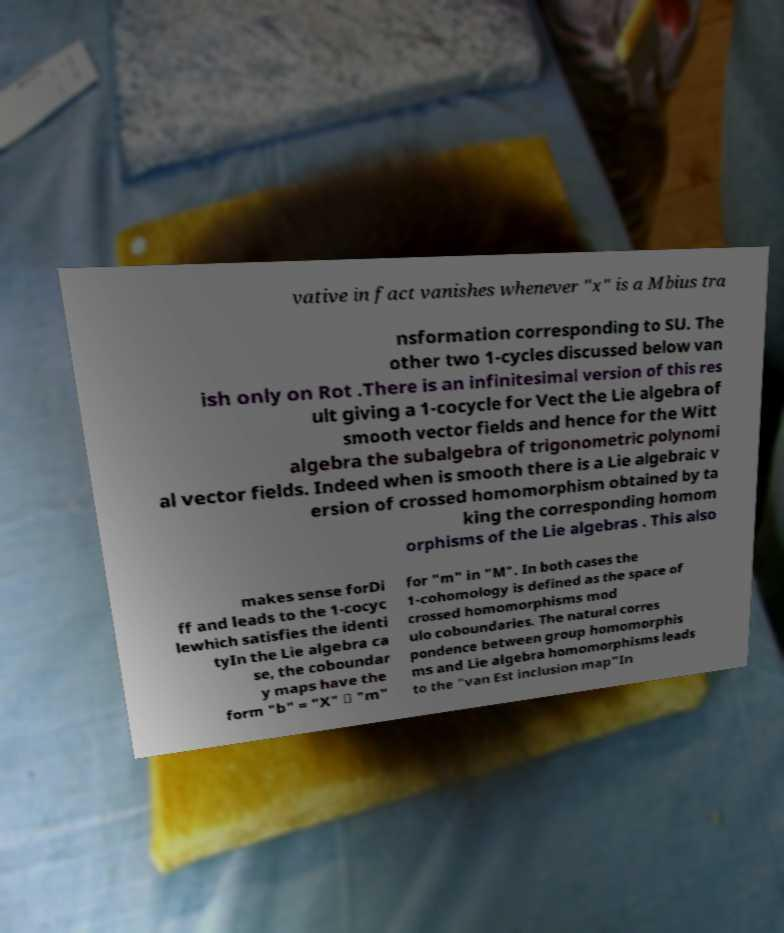Could you extract and type out the text from this image? vative in fact vanishes whenever "x" is a Mbius tra nsformation corresponding to SU. The other two 1-cycles discussed below van ish only on Rot .There is an infinitesimal version of this res ult giving a 1-cocycle for Vect the Lie algebra of smooth vector fields and hence for the Witt algebra the subalgebra of trigonometric polynomi al vector fields. Indeed when is smooth there is a Lie algebraic v ersion of crossed homomorphism obtained by ta king the corresponding homom orphisms of the Lie algebras . This also makes sense forDi ff and leads to the 1-cocyc lewhich satisfies the identi tyIn the Lie algebra ca se, the coboundar y maps have the form "b" = "X" ⋅ "m" for "m" in "M". In both cases the 1-cohomology is defined as the space of crossed homomorphisms mod ulo coboundaries. The natural corres pondence between group homomorphis ms and Lie algebra homomorphisms leads to the "van Est inclusion map"In 